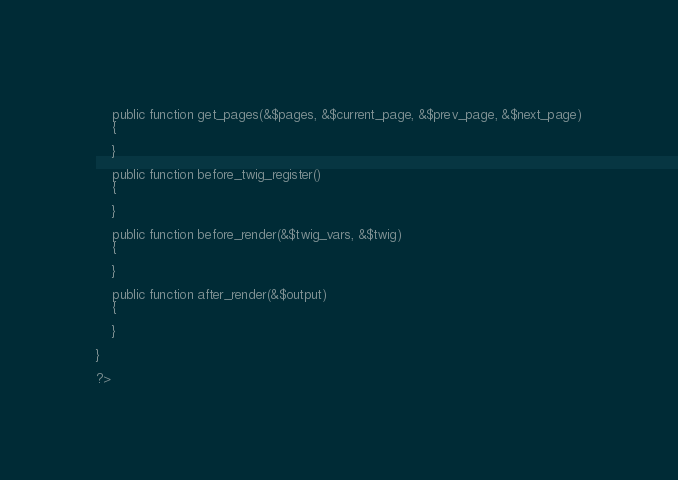Convert code to text. <code><loc_0><loc_0><loc_500><loc_500><_PHP_>	
	public function get_pages(&$pages, &$current_page, &$prev_page, &$next_page)
	{
		
	}
	
	public function before_twig_register()
	{
		
	}
	
	public function before_render(&$twig_vars, &$twig)
	{
		
	}
	
	public function after_render(&$output)
	{
		
	}
	
}

?></code> 